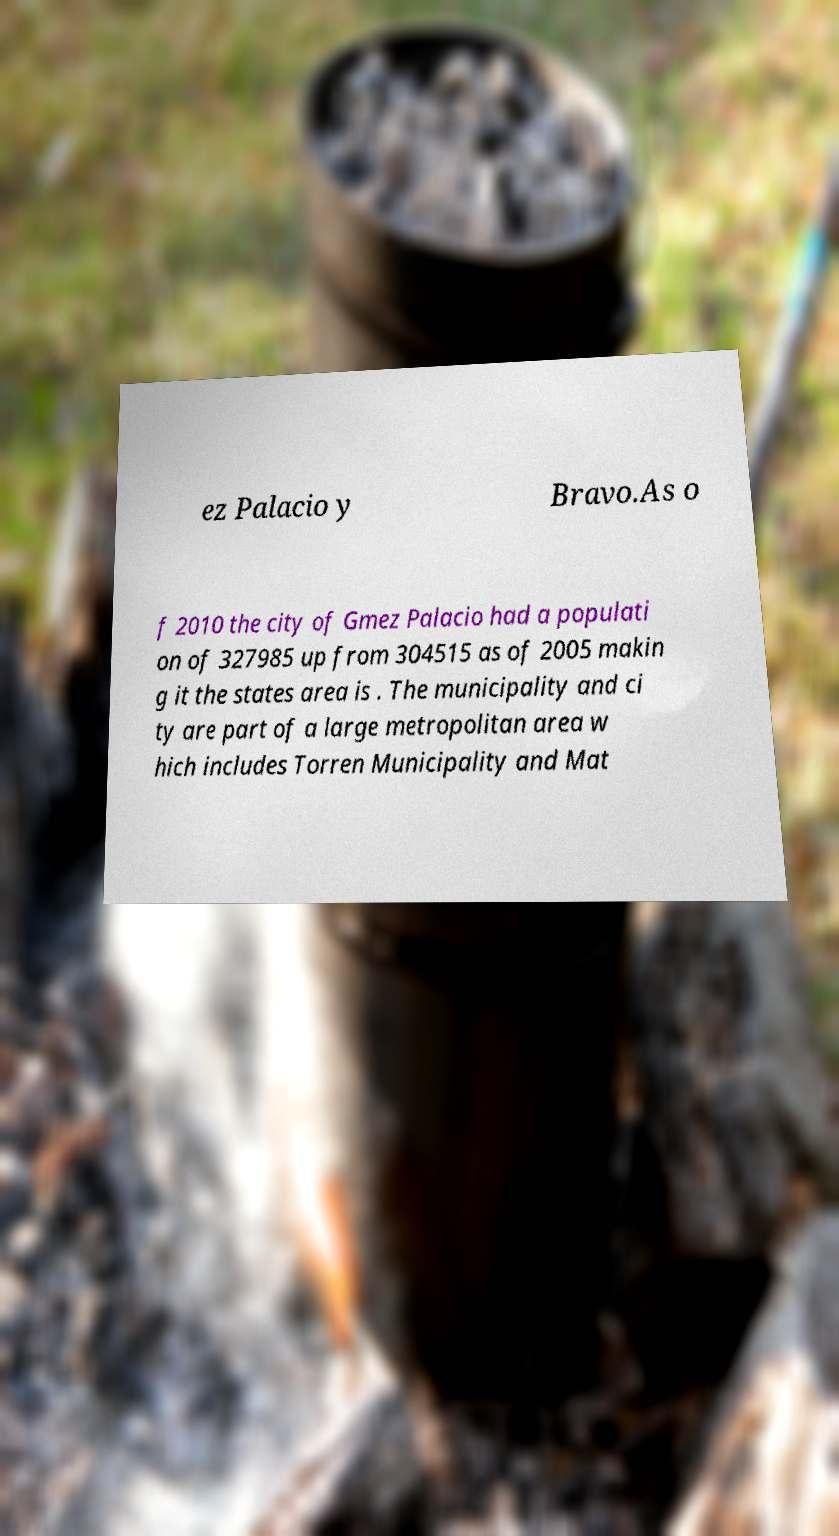Can you accurately transcribe the text from the provided image for me? ez Palacio y Bravo.As o f 2010 the city of Gmez Palacio had a populati on of 327985 up from 304515 as of 2005 makin g it the states area is . The municipality and ci ty are part of a large metropolitan area w hich includes Torren Municipality and Mat 